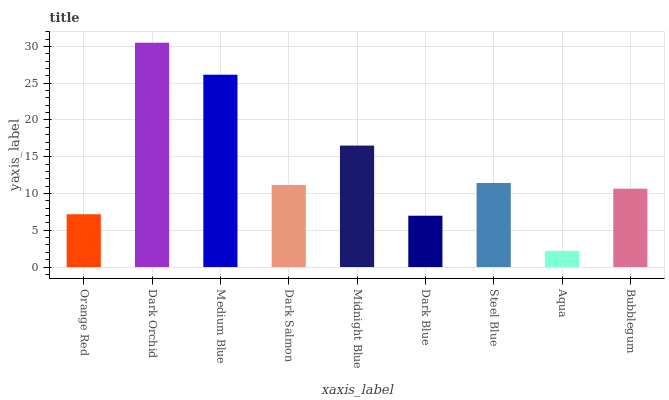Is Aqua the minimum?
Answer yes or no. Yes. Is Dark Orchid the maximum?
Answer yes or no. Yes. Is Medium Blue the minimum?
Answer yes or no. No. Is Medium Blue the maximum?
Answer yes or no. No. Is Dark Orchid greater than Medium Blue?
Answer yes or no. Yes. Is Medium Blue less than Dark Orchid?
Answer yes or no. Yes. Is Medium Blue greater than Dark Orchid?
Answer yes or no. No. Is Dark Orchid less than Medium Blue?
Answer yes or no. No. Is Dark Salmon the high median?
Answer yes or no. Yes. Is Dark Salmon the low median?
Answer yes or no. Yes. Is Medium Blue the high median?
Answer yes or no. No. Is Bubblegum the low median?
Answer yes or no. No. 